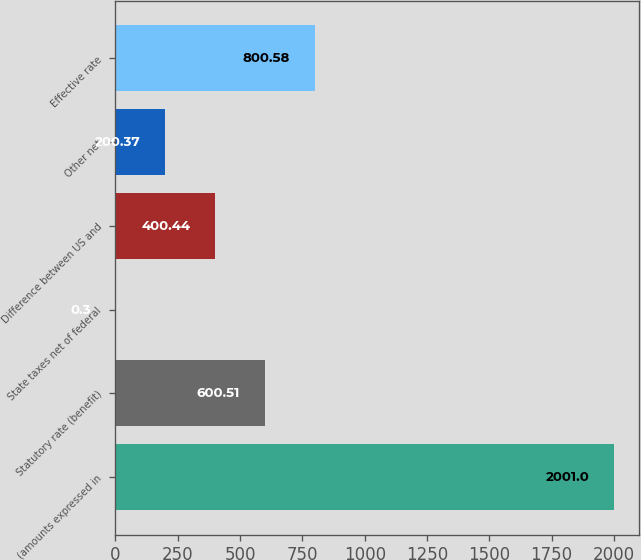<chart> <loc_0><loc_0><loc_500><loc_500><bar_chart><fcel>(amounts expressed in<fcel>Statutory rate (benefit)<fcel>State taxes net of federal<fcel>Difference between US and<fcel>Other net<fcel>Effective rate<nl><fcel>2001<fcel>600.51<fcel>0.3<fcel>400.44<fcel>200.37<fcel>800.58<nl></chart> 